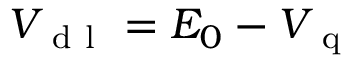Convert formula to latex. <formula><loc_0><loc_0><loc_500><loc_500>V _ { d l } = E _ { 0 } - V _ { q }</formula> 